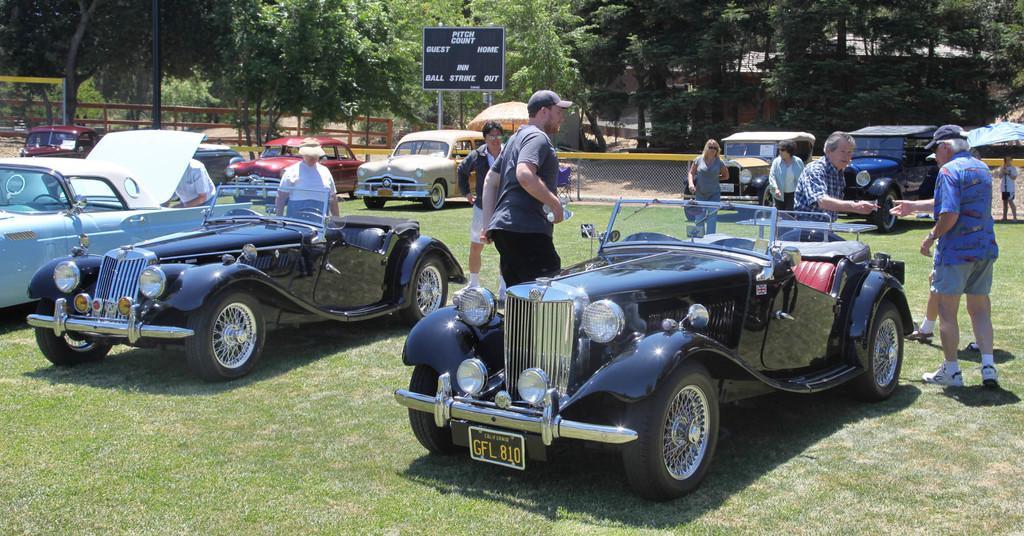How would you summarize this image in a sentence or two? This is an outside view. Here I can see many vehicles on the ground and there are few people standing. On the ground, I can see the grass. In the background there is a board on which I can see some text and there are many trees. On the left side there is railing. 